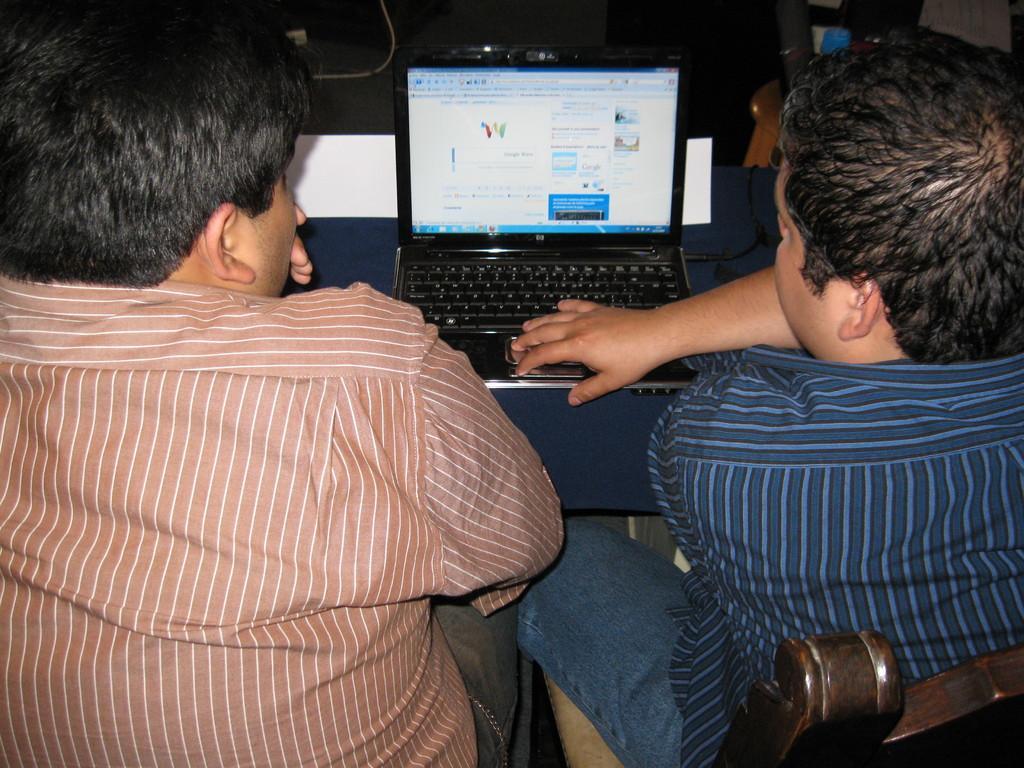Could you give a brief overview of what you see in this image? In this image there are two persons sitting on the chairs, in front of them there is a table. On the table there is a laptop and a cable connected to it. On the top right side of the image there are few objects which are unclear. 